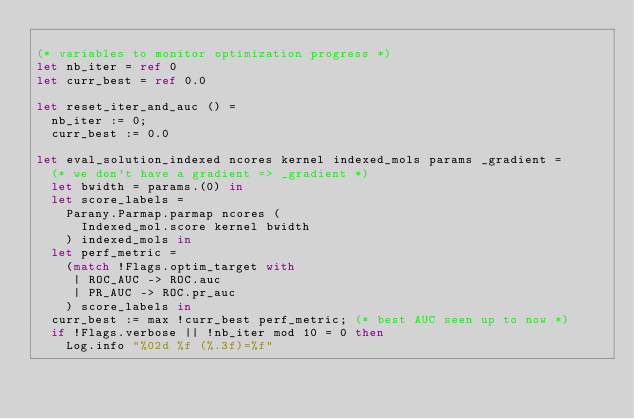Convert code to text. <code><loc_0><loc_0><loc_500><loc_500><_OCaml_>
(* variables to monitor optimization progress *)
let nb_iter = ref 0
let curr_best = ref 0.0

let reset_iter_and_auc () =
  nb_iter := 0;
  curr_best := 0.0

let eval_solution_indexed ncores kernel indexed_mols params _gradient =
  (* we don't have a gradient => _gradient *)
  let bwidth = params.(0) in
  let score_labels =
    Parany.Parmap.parmap ncores (
      Indexed_mol.score kernel bwidth
    ) indexed_mols in
  let perf_metric =
    (match !Flags.optim_target with
     | ROC_AUC -> ROC.auc
     | PR_AUC -> ROC.pr_auc
    ) score_labels in
  curr_best := max !curr_best perf_metric; (* best AUC seen up to now *)
  if !Flags.verbose || !nb_iter mod 10 = 0 then
    Log.info "%02d %f (%.3f)=%f"</code> 